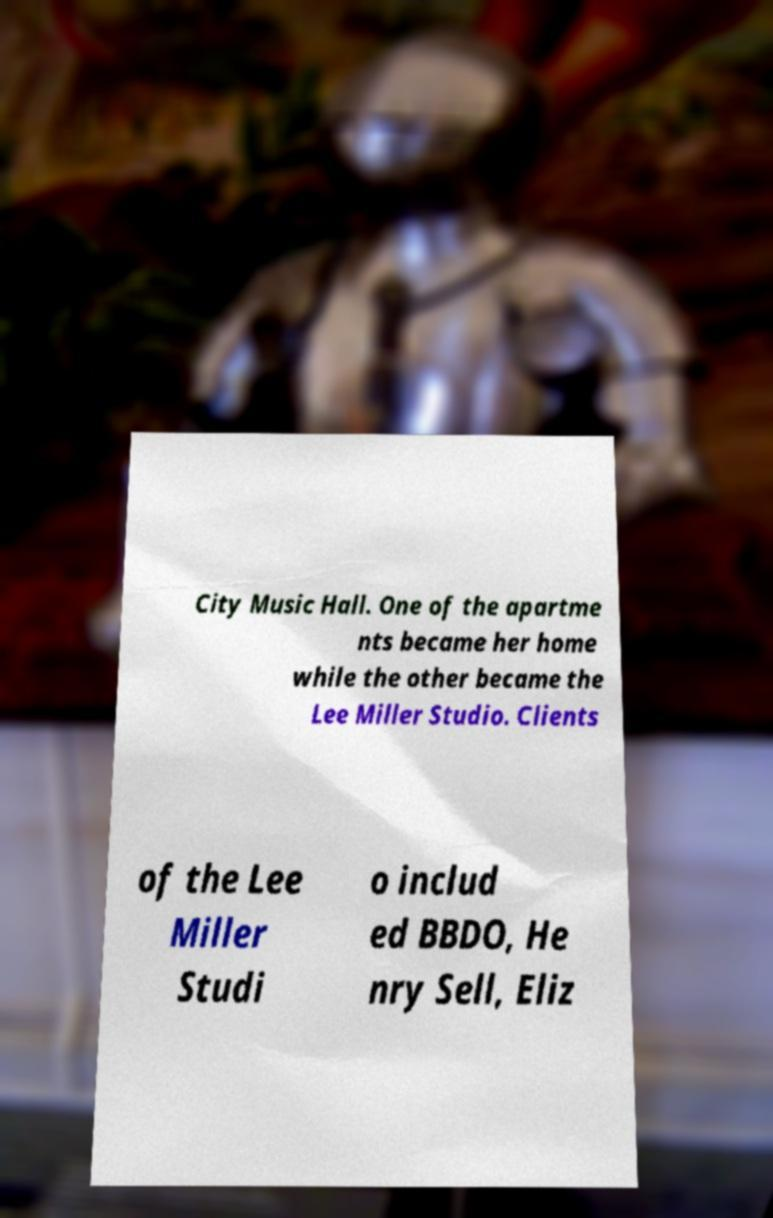Could you assist in decoding the text presented in this image and type it out clearly? City Music Hall. One of the apartme nts became her home while the other became the Lee Miller Studio. Clients of the Lee Miller Studi o includ ed BBDO, He nry Sell, Eliz 